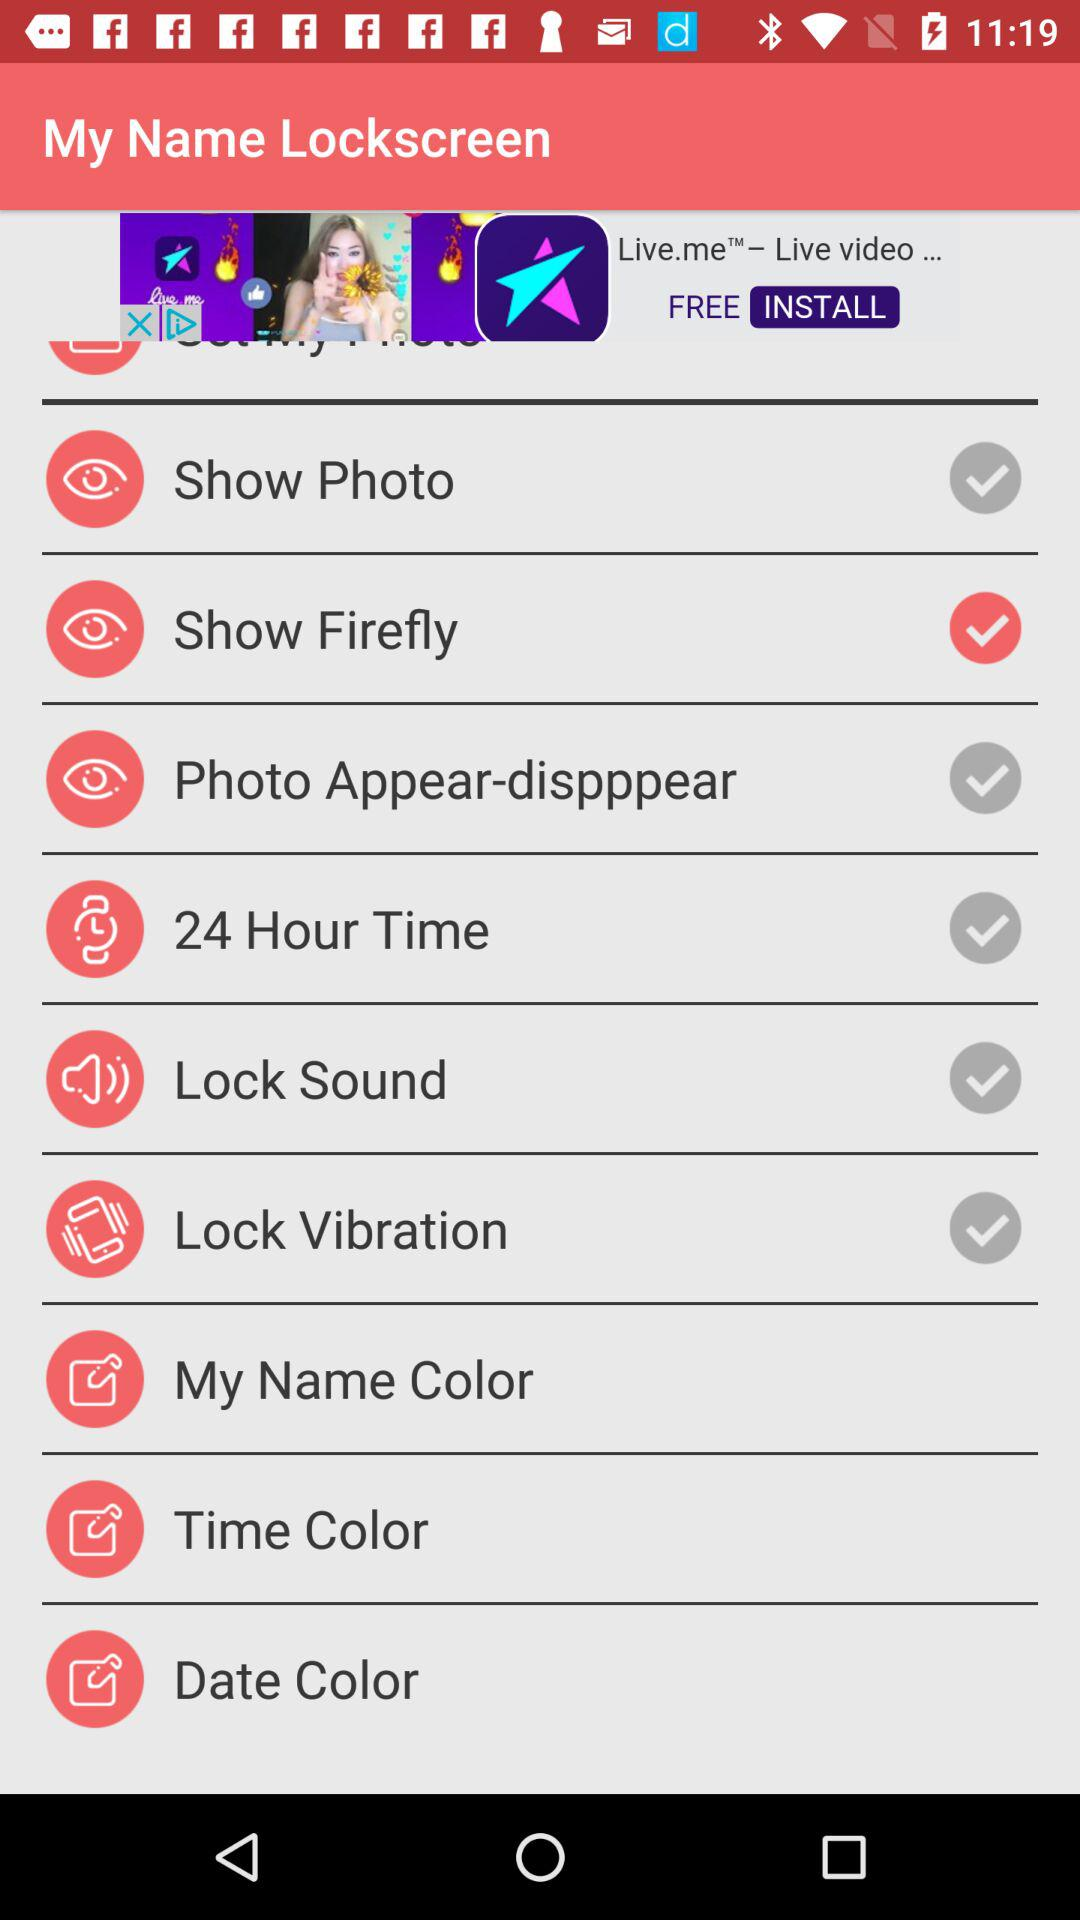What's the status of "Show Firefly"? The status is "on". 